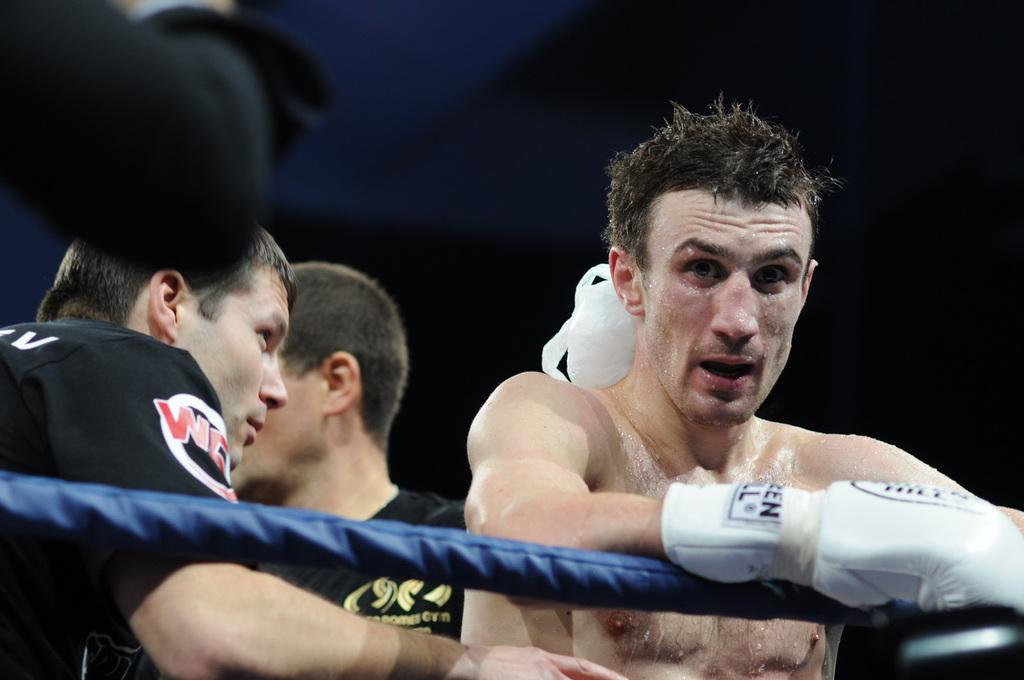What is happening in the image? There are people in the boxing ring. Can you describe any specific details about the people in the image? There is an ice pack on one person's neck. What is the weather like in the boxing ring? The provided facts do not mention the weather, so it cannot be determined from the image. 